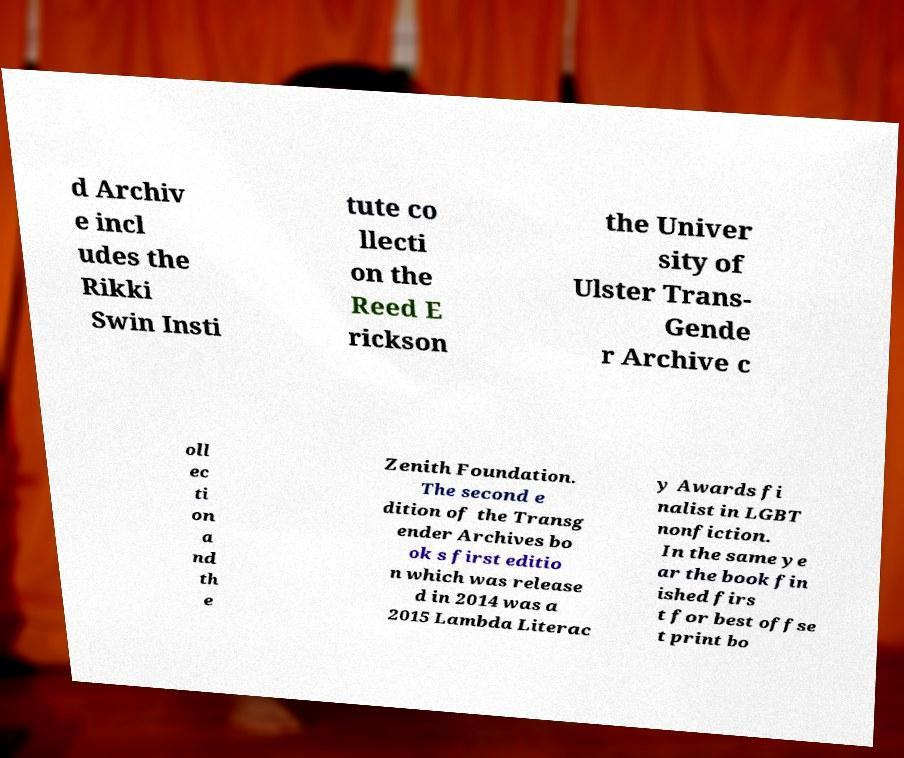Please identify and transcribe the text found in this image. d Archiv e incl udes the Rikki Swin Insti tute co llecti on the Reed E rickson the Univer sity of Ulster Trans- Gende r Archive c oll ec ti on a nd th e Zenith Foundation. The second e dition of the Transg ender Archives bo ok s first editio n which was release d in 2014 was a 2015 Lambda Literac y Awards fi nalist in LGBT nonfiction. In the same ye ar the book fin ished firs t for best offse t print bo 